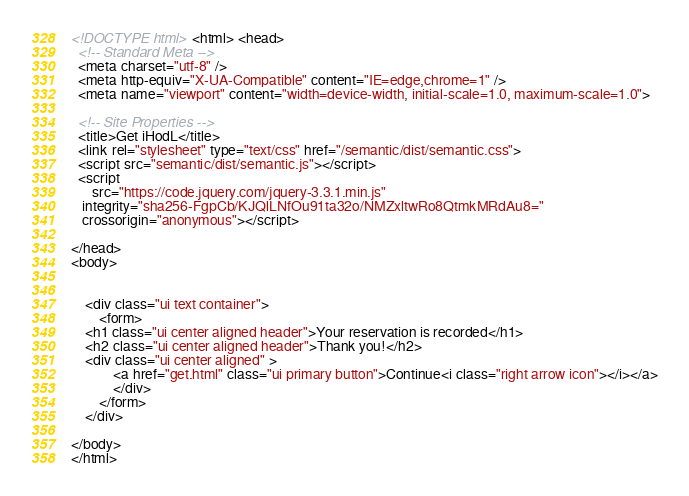Convert code to text. <code><loc_0><loc_0><loc_500><loc_500><_HTML_><!DOCTYPE html> <html> <head>
  <!-- Standard Meta -->
  <meta charset="utf-8" />
  <meta http-equiv="X-UA-Compatible" content="IE=edge,chrome=1" />
  <meta name="viewport" content="width=device-width, initial-scale=1.0, maximum-scale=1.0">

  <!-- Site Properties -->
  <title>Get iHodL</title>
  <link rel="stylesheet" type="text/css" href="/semantic/dist/semantic.css">
  <script src="semantic/dist/semantic.js"></script>
  <script
	  src="https://code.jquery.com/jquery-3.3.1.min.js"
   integrity="sha256-FgpCb/KJQlLNfOu91ta32o/NMZxltwRo8QtmkMRdAu8="
   crossorigin="anonymous"></script>

</head>
<body>


    <div class="ui text container">
		<form>
	<h1 class="ui center aligned header">Your reservation is recorded</h1>
	<h2 class="ui center aligned header">Thank you!</h2>
	<div class="ui center aligned" >
			<a href="get.html" class="ui primary button">Continue<i class="right arrow icon"></i></a>
			</div>
		</form>
    </div>
	
</body>
</html>
</code> 